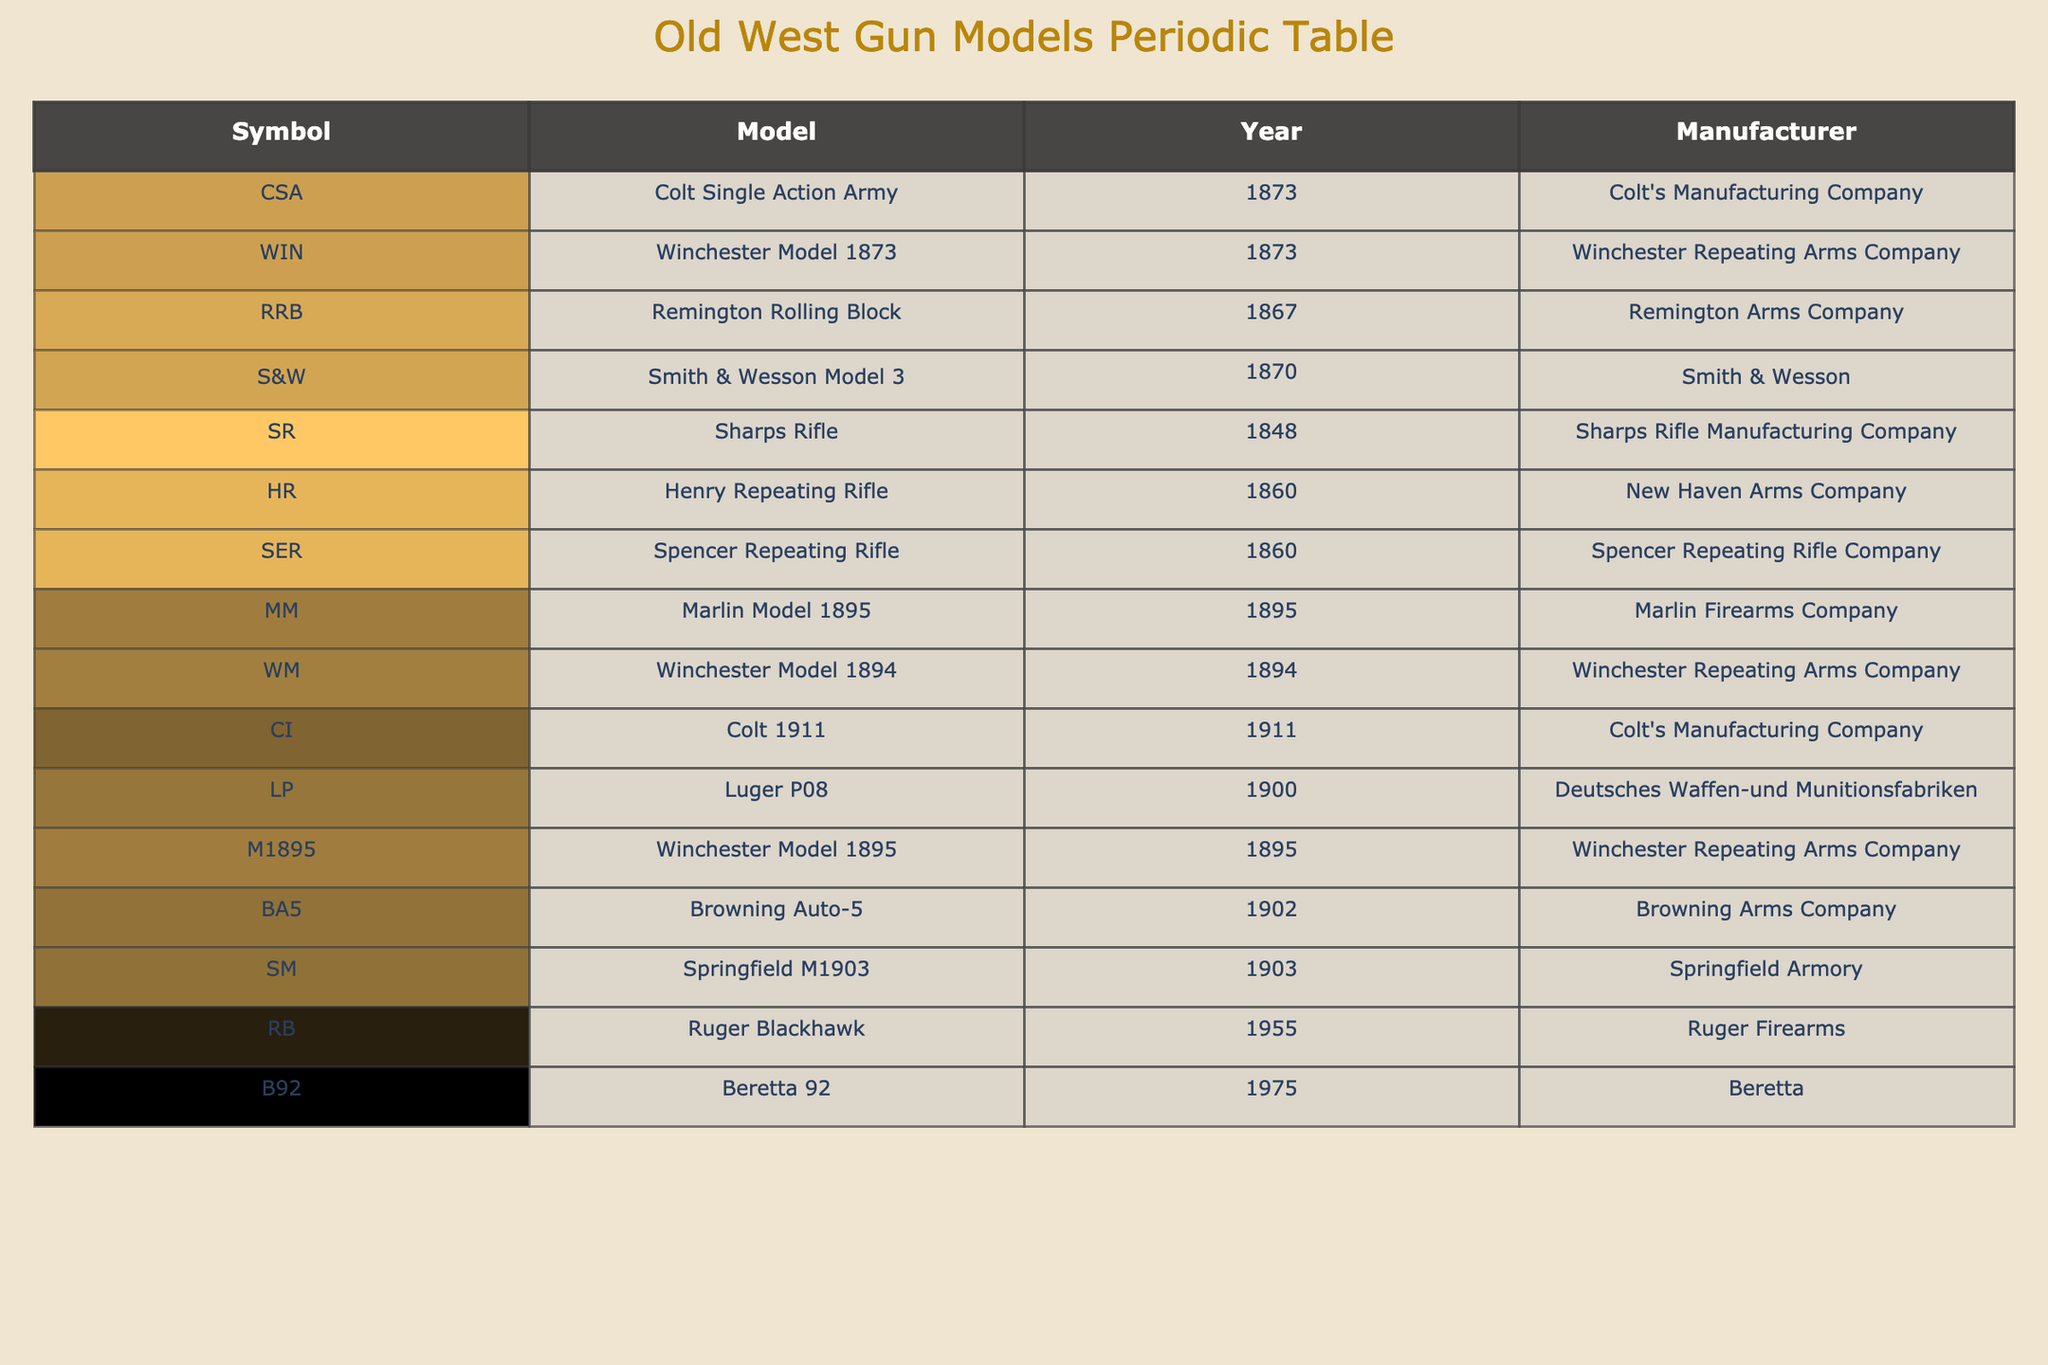What is the manufacturing year of the Colt Single Action Army? The Colt Single Action Army is listed in the table, and its corresponding manufacturing year is indicated in that row. Checking the 'Manufacturing Year' column for the row where the 'Model' is "Colt Single Action Army," it shows 1873.
Answer: 1873 Which model was manufactured by the Sharps Rifle Manufacturing Company? The 'Manufacturer' column lists the manufacturers for each gun model. By looking at the 'Model' associated with "Sharps Rifle Manufacturing Company," we see that the model is "Sharps Rifle."
Answer: Sharps Rifle Is the Winchester Model 1873 the only model represented in the year 1873? To answer this, we check the table for any other models listed under the manufacturing year 1873. The table shows both the Colt Single Action Army and Winchester Model 1873 were manufactured in that year. Therefore, it is not the only model from that year.
Answer: No What is the earliest manufacturing year in the table and which model corresponds to it? To identify the earliest manufacturing year, I will examine the 'Manufacturing Year' column to find the minimum value. The minimum year is 1848, which corresponds to the "Sharps Rifle" model in the table.
Answer: 1848, Sharps Rifle How many models were manufactured after 1900, and what are their names? To determine the number of models manufactured after 1900, I will check the 'Manufacturing Year' column for values greater than 1900 and count them. The models with manufacturing years after 1900 are: Luger P08 (1900), Browning Auto-5 (1902), Springfield M1903 (1903), Ruger Blackhawk (1955), and Beretta 92 (1975). Counting them gives a total of 5 models.
Answer: 5: Luger P08, Browning Auto-5, Springfield M1903, Ruger Blackhawk, Beretta 92 Which manufacturer produced the most number of models listed in the table? We can analyze the 'Manufacturer' column and count the occurrences of each manufacturer. Colt's Manufacturing Company has 2 models (Colt Single Action Army and Colt 1911), Winchester Repeating Arms Company also has 3 models (Winchester Model 1873, Winchester Model 1894, M1895 Winchester Lever Action). The highest count indicates that Winchester Repeating Arms Company produced the most models.
Answer: Winchester Repeating Arms Company What is the difference in manufacturing years between the earliest and latest model in the table? To calculate the difference, locate the earliest year (1848) from the Sharps Rifle and the latest year (1975) from the Beretta 92. The difference is calculated as 1975 - 1848 = 127 years.
Answer: 127 Is there a model manufactured by Beretta? Checking the 'Manufacturer' column reveals that Beretta is listed as the manufacturer for the model "Beretta 92." Therefore, the statement is true.
Answer: Yes What are the models associated with the manufacturer Smith & Wesson? Looking into the table, I will find the rows under the 'Manufacturer' column that match "Smith & Wesson." The corresponding model listed is the "Smith & Wesson Model 3."
Answer: Smith & Wesson Model 3 